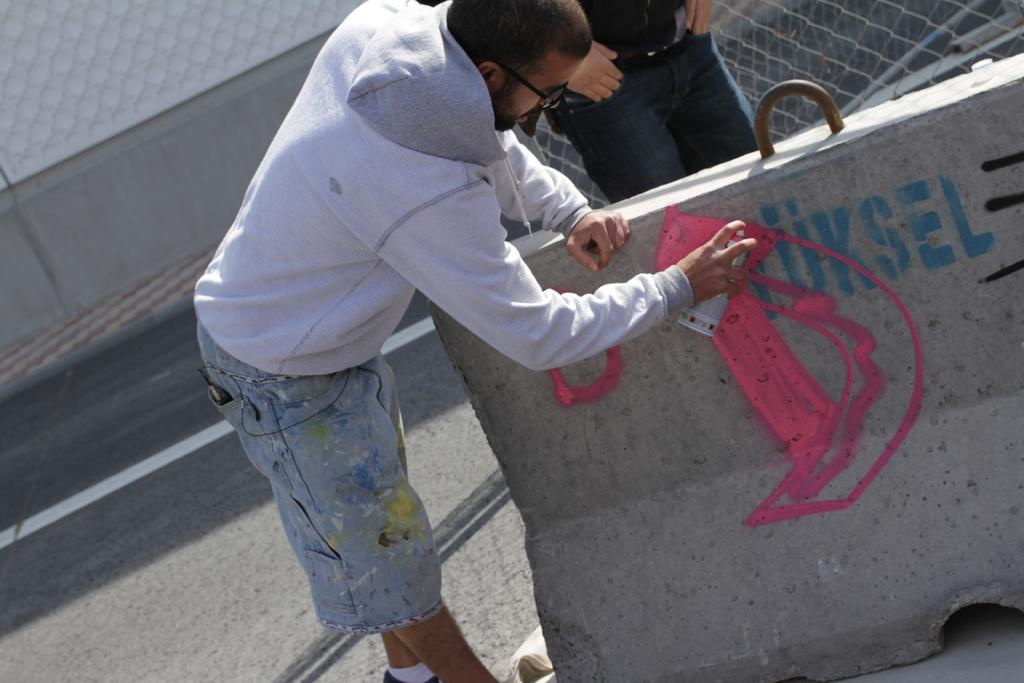How many people are standing on the road in the image? There are two men standing on the road in the image. What is one of the men holding in his hand? One of the men is holding an object in his hand. What can be seen on the road in the image? There is a concrete barricade on the road. What hobbies do the men have in common, as seen in the image? There is no information about the men's hobbies in the image, so we cannot determine any common hobbies. Can you tell me how long the bridge in the image is? There is no bridge present in the image, so we cannot determine its length. 